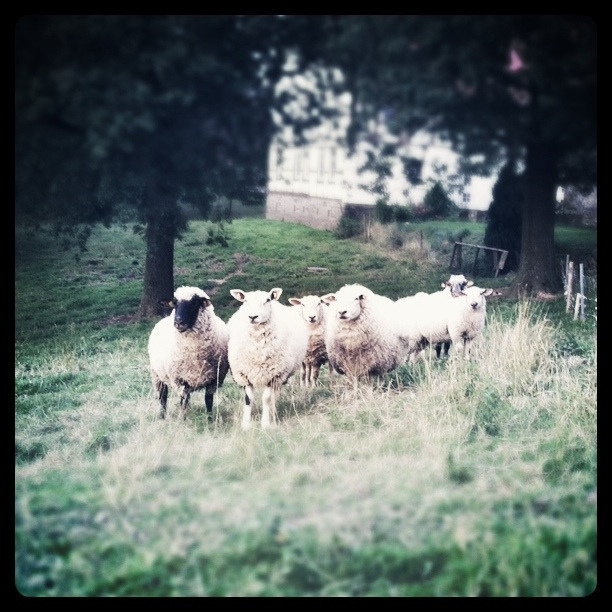Describe the objects in this image and their specific colors. I can see sheep in black, lightgray, darkgray, and gray tones, sheep in black, white, darkgray, and lightgray tones, sheep in black, white, darkgray, and gray tones, sheep in black, white, darkgray, and gray tones, and sheep in black, lightgray, gray, and darkgray tones in this image. 